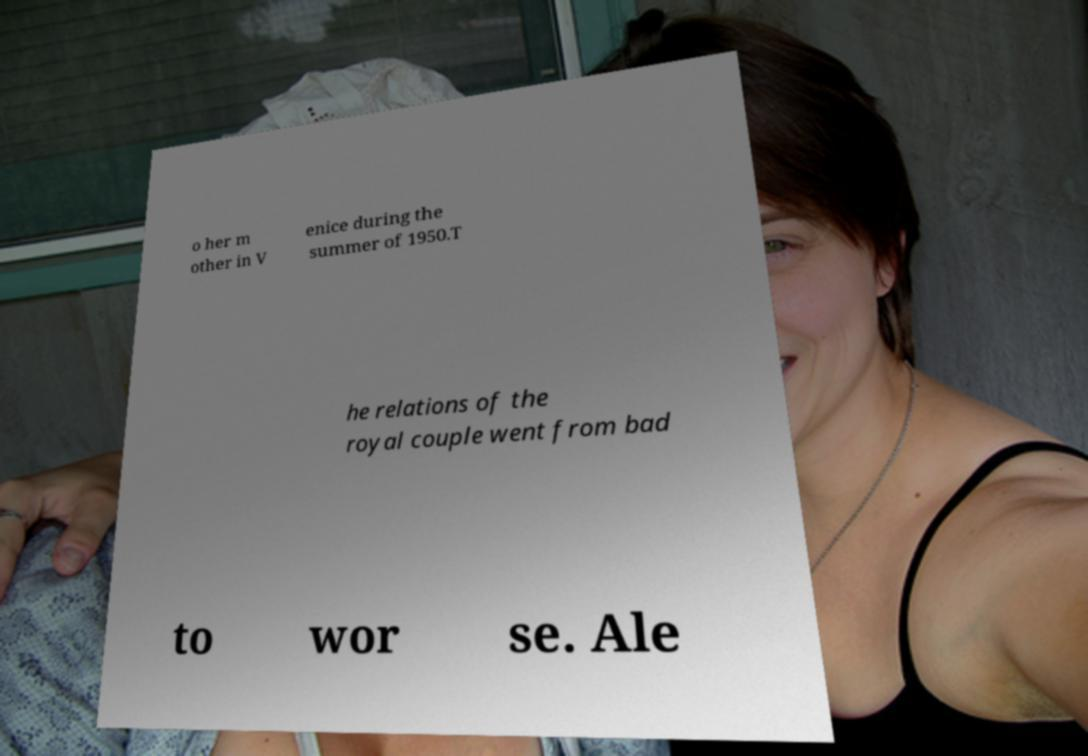There's text embedded in this image that I need extracted. Can you transcribe it verbatim? o her m other in V enice during the summer of 1950.T he relations of the royal couple went from bad to wor se. Ale 